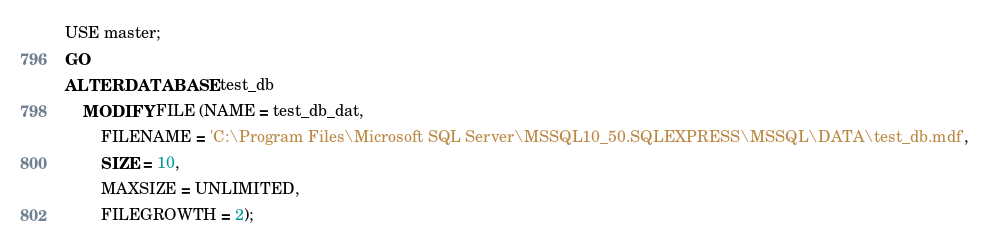<code> <loc_0><loc_0><loc_500><loc_500><_SQL_>USE master;
GO
ALTER DATABASE test_db
	MODIFY FILE (NAME = test_db_dat,
		FILENAME = 'C:\Program Files\Microsoft SQL Server\MSSQL10_50.SQLEXPRESS\MSSQL\DATA\test_db.mdf',
		SIZE = 10,
		MAXSIZE = UNLIMITED,
		FILEGROWTH = 2);</code> 